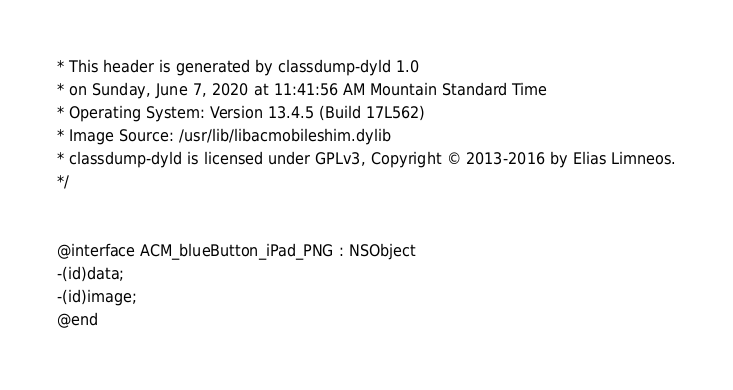Convert code to text. <code><loc_0><loc_0><loc_500><loc_500><_C_>* This header is generated by classdump-dyld 1.0
* on Sunday, June 7, 2020 at 11:41:56 AM Mountain Standard Time
* Operating System: Version 13.4.5 (Build 17L562)
* Image Source: /usr/lib/libacmobileshim.dylib
* classdump-dyld is licensed under GPLv3, Copyright © 2013-2016 by Elias Limneos.
*/


@interface ACM_blueButton_iPad_PNG : NSObject
-(id)data;
-(id)image;
@end

</code> 